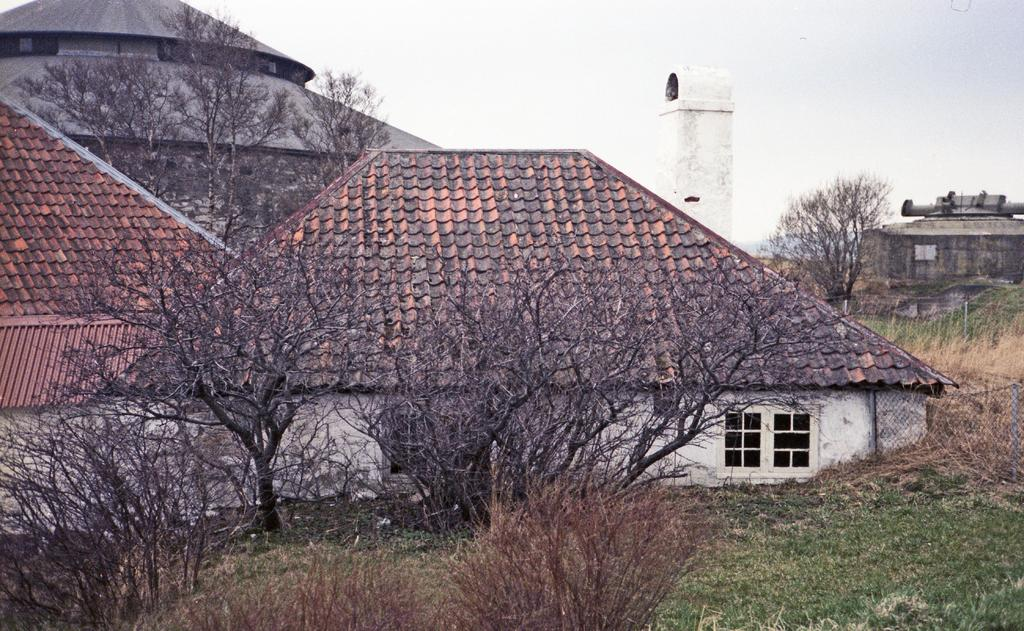What type of structures can be seen in the image? There are houses, a building, and a tower in the image. What natural elements are present in the image? There are trees and grass on the ground in the image. What type of barrier is visible in the image? There is a metal fence in the image. How would you describe the sky in the image? The sky is cloudy in the image. Where are the dolls placed in the image? There are no dolls present in the image. What tasks is the maid performing in the image? There is no maid present in the image. 